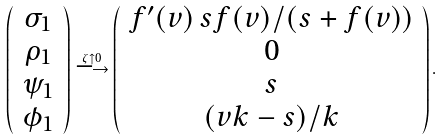Convert formula to latex. <formula><loc_0><loc_0><loc_500><loc_500>\left ( \begin{array} { c } \sigma _ { 1 } \\ \rho _ { 1 } \\ \psi _ { 1 } \\ \phi _ { 1 } \end{array} \right ) \stackrel { \zeta \uparrow 0 } { \longrightarrow } \left ( \begin{array} { c } f ^ { \prime } ( v ) \, s f ( v ) / ( s + f ( v ) ) \\ 0 \\ s \\ ( v k - s ) / k \end{array} \right ) .</formula> 